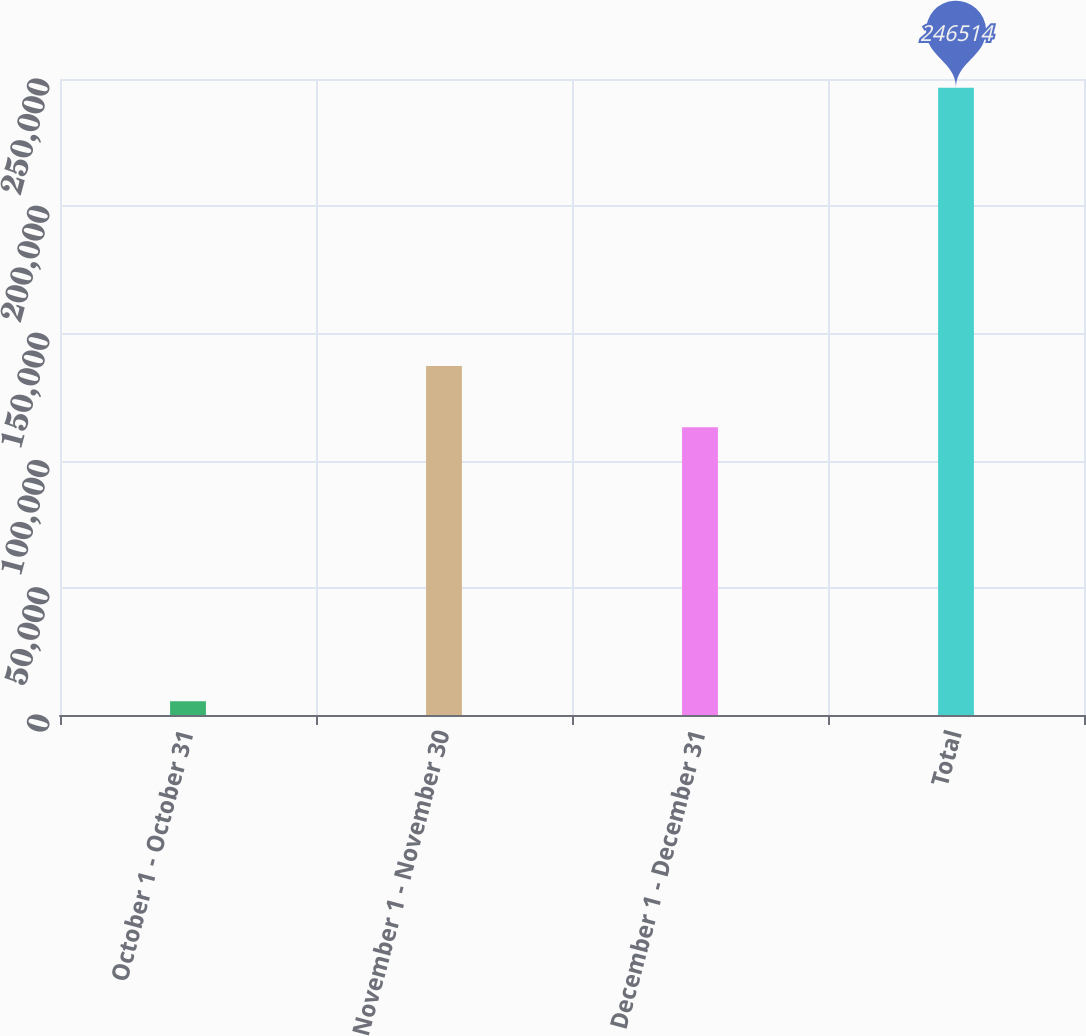Convert chart to OTSL. <chart><loc_0><loc_0><loc_500><loc_500><bar_chart><fcel>October 1 - October 31<fcel>November 1 - November 30<fcel>December 1 - December 31<fcel>Total<nl><fcel>5404<fcel>137196<fcel>113085<fcel>246514<nl></chart> 